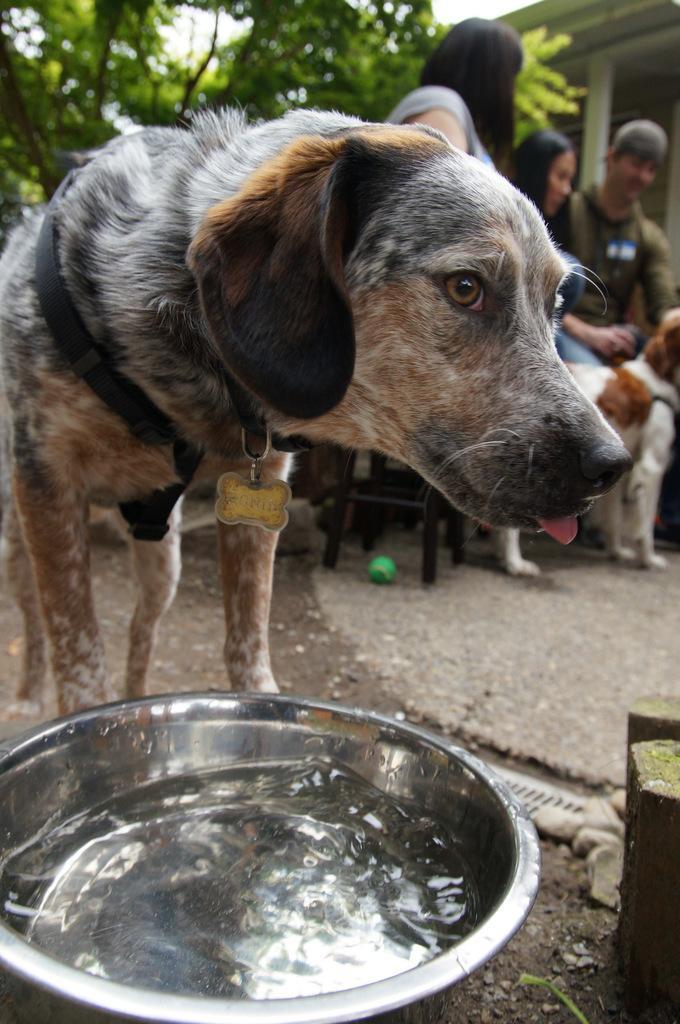Could you give a brief overview of what you see in this image? On the background of the picture we can see a pillar, tree and alos two persons sitting on the chairs. This is a ball in green colour. Here we can see one dog standing and this is a bowl with water. 